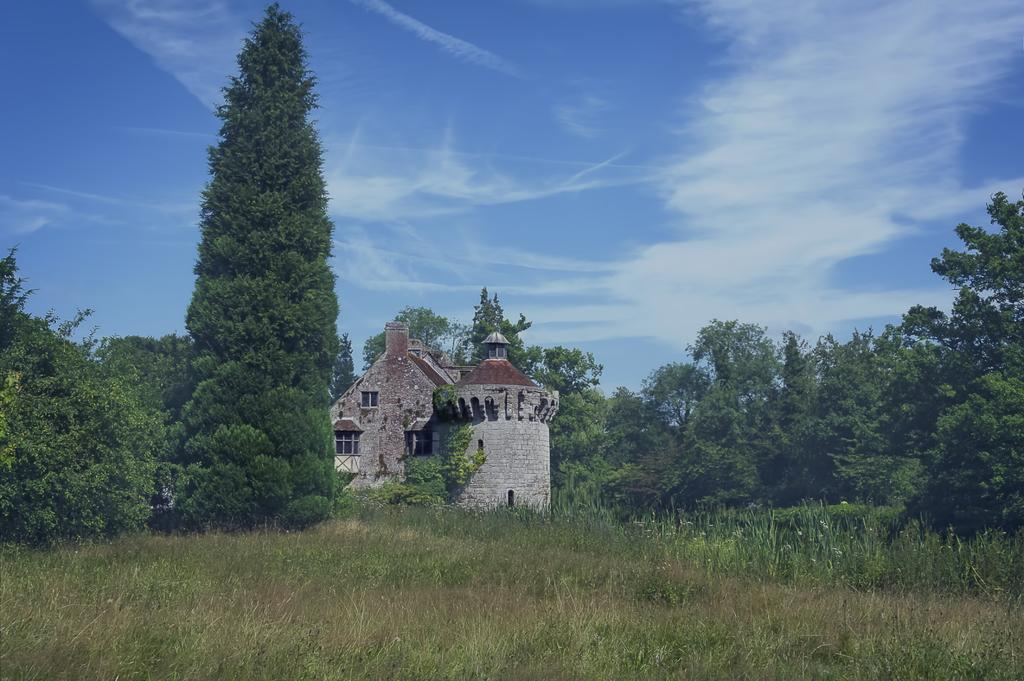What type of natural elements are present in the image? The image contains trees and plants. What type of ground cover can be seen at the bottom of the image? There is grass at the bottom of the image. What type of structure is located in the middle of the image? There is a house in the middle of the image. What is visible at the top of the image? The sky is visible at the top of the image. What type of button can be seen on the farm in the image? There is no button or farm present in the image. What type of experience can be gained from visiting the plants in the image? The image does not depict a specific experience or activity related to the plants. 